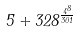Convert formula to latex. <formula><loc_0><loc_0><loc_500><loc_500>5 + 3 2 8 ^ { \frac { 4 ^ { 8 } } { 3 0 1 } }</formula> 